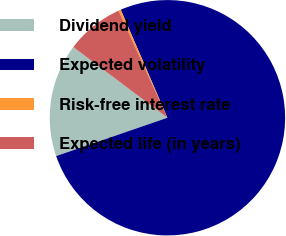Convert chart to OTSL. <chart><loc_0><loc_0><loc_500><loc_500><pie_chart><fcel>Dividend yield<fcel>Expected volatility<fcel>Risk-free interest rate<fcel>Expected life (in years)<nl><fcel>15.53%<fcel>76.21%<fcel>0.33%<fcel>7.93%<nl></chart> 